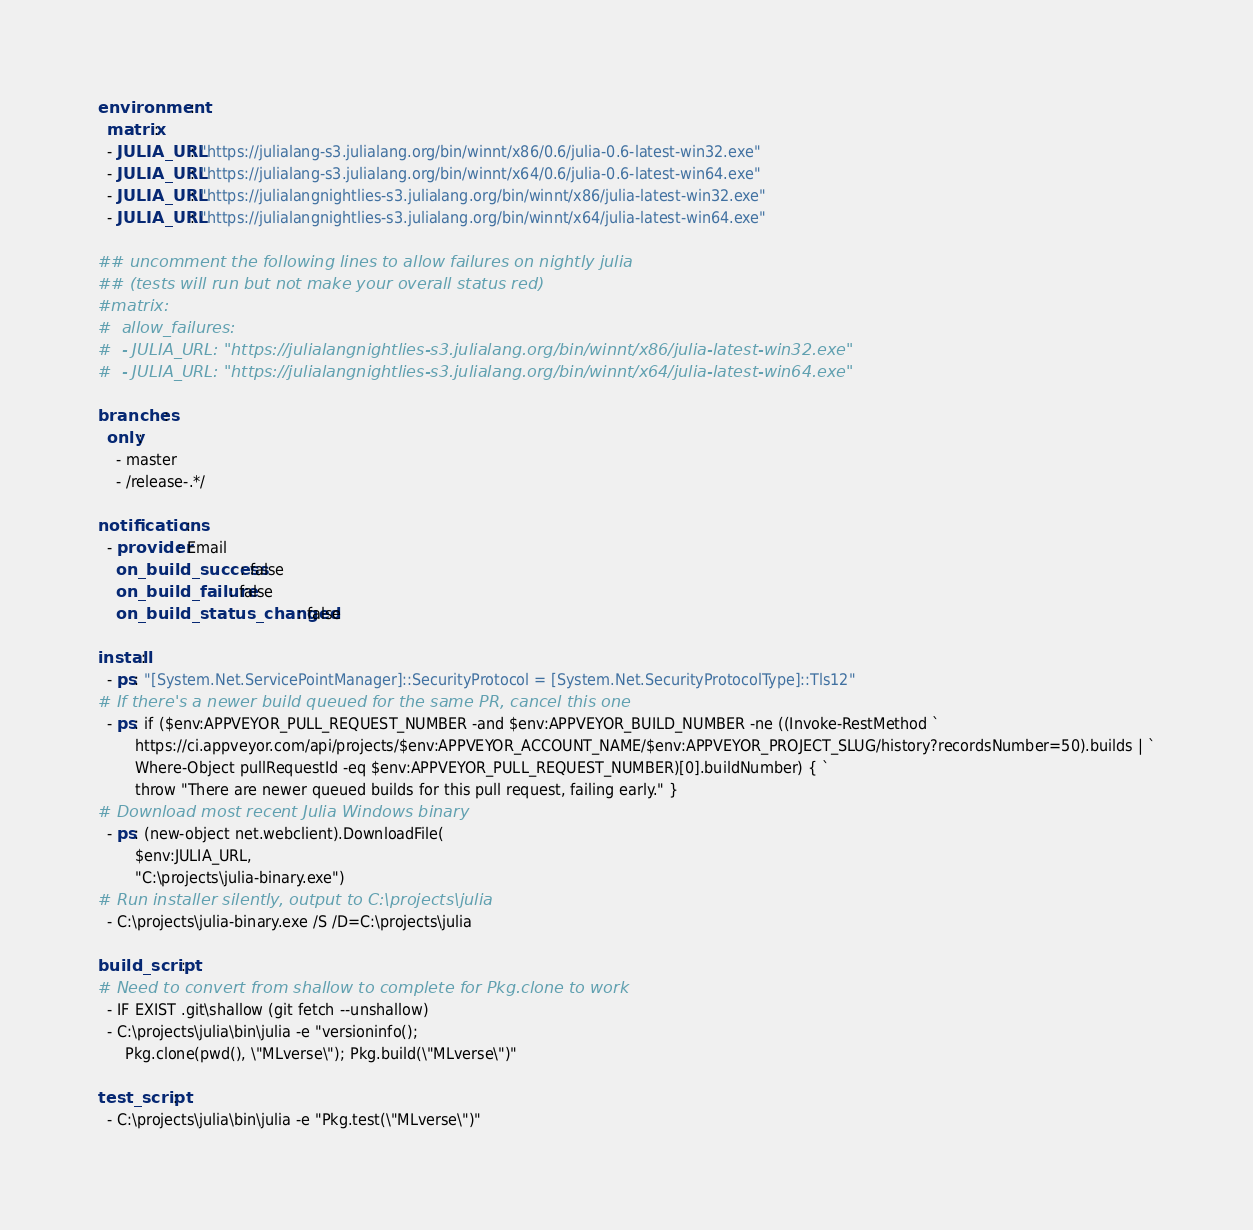<code> <loc_0><loc_0><loc_500><loc_500><_YAML_>environment:
  matrix:
  - JULIA_URL: "https://julialang-s3.julialang.org/bin/winnt/x86/0.6/julia-0.6-latest-win32.exe"
  - JULIA_URL: "https://julialang-s3.julialang.org/bin/winnt/x64/0.6/julia-0.6-latest-win64.exe"
  - JULIA_URL: "https://julialangnightlies-s3.julialang.org/bin/winnt/x86/julia-latest-win32.exe"
  - JULIA_URL: "https://julialangnightlies-s3.julialang.org/bin/winnt/x64/julia-latest-win64.exe"

## uncomment the following lines to allow failures on nightly julia
## (tests will run but not make your overall status red)
#matrix:
#  allow_failures:
#  - JULIA_URL: "https://julialangnightlies-s3.julialang.org/bin/winnt/x86/julia-latest-win32.exe"
#  - JULIA_URL: "https://julialangnightlies-s3.julialang.org/bin/winnt/x64/julia-latest-win64.exe"

branches:
  only:
    - master
    - /release-.*/

notifications:
  - provider: Email
    on_build_success: false
    on_build_failure: false
    on_build_status_changed: false

install:
  - ps: "[System.Net.ServicePointManager]::SecurityProtocol = [System.Net.SecurityProtocolType]::Tls12"
# If there's a newer build queued for the same PR, cancel this one
  - ps: if ($env:APPVEYOR_PULL_REQUEST_NUMBER -and $env:APPVEYOR_BUILD_NUMBER -ne ((Invoke-RestMethod `
        https://ci.appveyor.com/api/projects/$env:APPVEYOR_ACCOUNT_NAME/$env:APPVEYOR_PROJECT_SLUG/history?recordsNumber=50).builds | `
        Where-Object pullRequestId -eq $env:APPVEYOR_PULL_REQUEST_NUMBER)[0].buildNumber) { `
        throw "There are newer queued builds for this pull request, failing early." }
# Download most recent Julia Windows binary
  - ps: (new-object net.webclient).DownloadFile(
        $env:JULIA_URL,
        "C:\projects\julia-binary.exe")
# Run installer silently, output to C:\projects\julia
  - C:\projects\julia-binary.exe /S /D=C:\projects\julia

build_script:
# Need to convert from shallow to complete for Pkg.clone to work
  - IF EXIST .git\shallow (git fetch --unshallow)
  - C:\projects\julia\bin\julia -e "versioninfo();
      Pkg.clone(pwd(), \"MLverse\"); Pkg.build(\"MLverse\")"

test_script:
  - C:\projects\julia\bin\julia -e "Pkg.test(\"MLverse\")"
</code> 